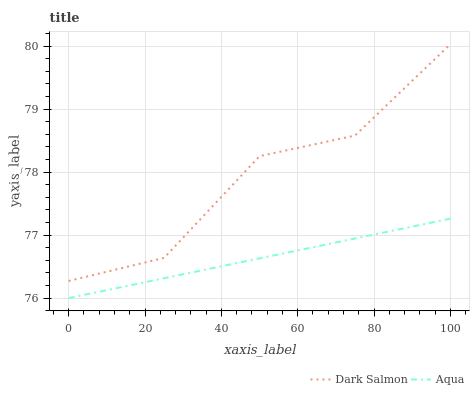Does Aqua have the minimum area under the curve?
Answer yes or no. Yes. Does Dark Salmon have the maximum area under the curve?
Answer yes or no. Yes. Does Dark Salmon have the minimum area under the curve?
Answer yes or no. No. Is Aqua the smoothest?
Answer yes or no. Yes. Is Dark Salmon the roughest?
Answer yes or no. Yes. Is Dark Salmon the smoothest?
Answer yes or no. No. Does Dark Salmon have the lowest value?
Answer yes or no. No. Does Dark Salmon have the highest value?
Answer yes or no. Yes. Is Aqua less than Dark Salmon?
Answer yes or no. Yes. Is Dark Salmon greater than Aqua?
Answer yes or no. Yes. Does Aqua intersect Dark Salmon?
Answer yes or no. No. 